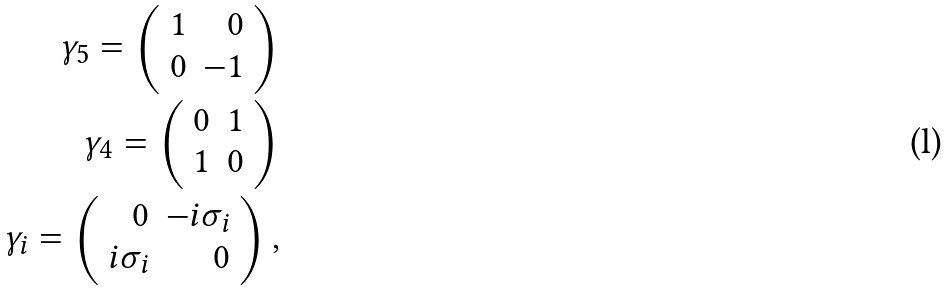Convert formula to latex. <formula><loc_0><loc_0><loc_500><loc_500>\gamma _ { 5 } = \left ( \begin{array} { r r } 1 & 0 \\ 0 & - 1 \end{array} \right ) \\ \gamma _ { 4 } = \left ( \begin{array} { r r } 0 & 1 \\ 1 & 0 \end{array} \right ) \\ \gamma _ { i } = \left ( \begin{array} { r r } 0 & - i \sigma _ { i } \\ i \sigma _ { i } & 0 \end{array} \right ) ,</formula> 